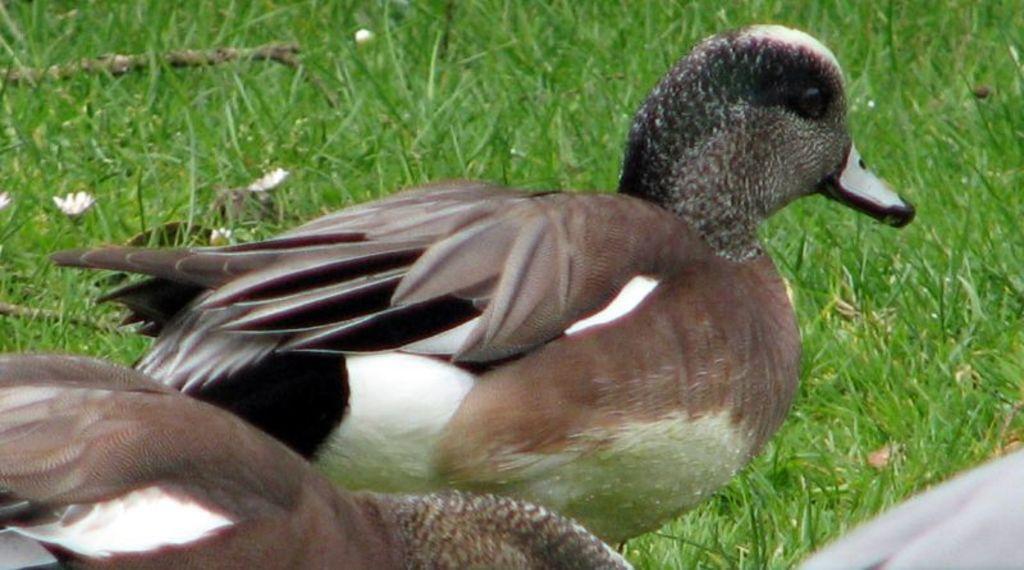Can you describe this image briefly? In this image we can see ducks, flowers, and the grass. 